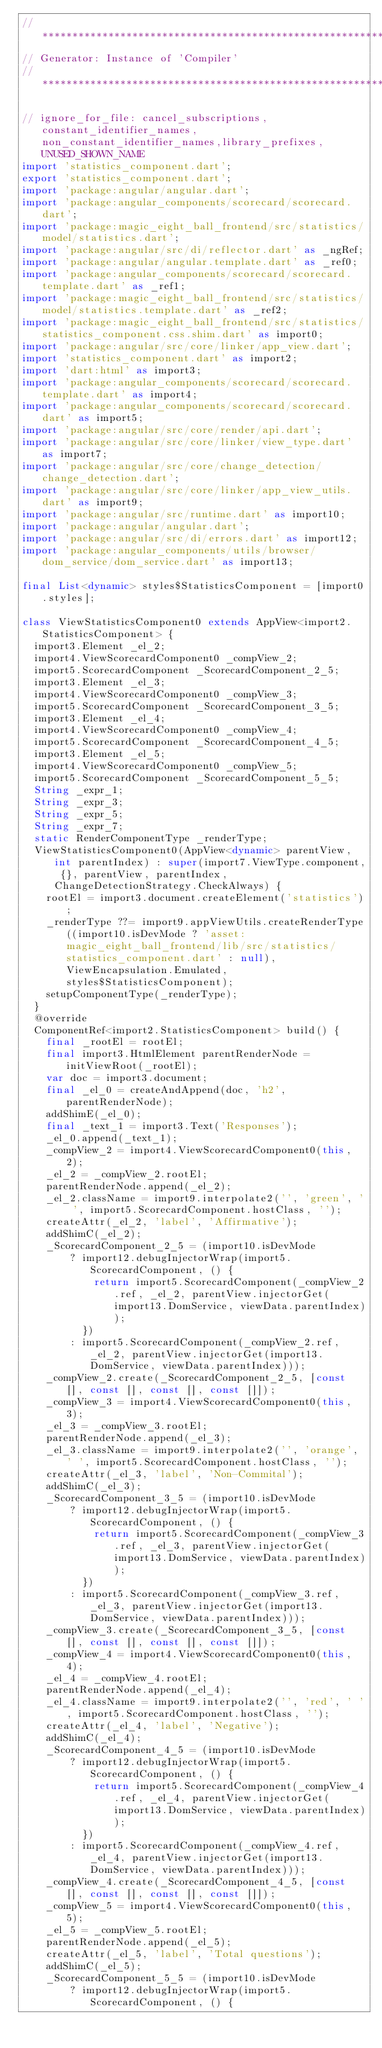Convert code to text. <code><loc_0><loc_0><loc_500><loc_500><_Dart_>// **************************************************************************
// Generator: Instance of 'Compiler'
// **************************************************************************

// ignore_for_file: cancel_subscriptions,constant_identifier_names,non_constant_identifier_names,library_prefixes,UNUSED_SHOWN_NAME
import 'statistics_component.dart';
export 'statistics_component.dart';
import 'package:angular/angular.dart';
import 'package:angular_components/scorecard/scorecard.dart';
import 'package:magic_eight_ball_frontend/src/statistics/model/statistics.dart';
import 'package:angular/src/di/reflector.dart' as _ngRef;
import 'package:angular/angular.template.dart' as _ref0;
import 'package:angular_components/scorecard/scorecard.template.dart' as _ref1;
import 'package:magic_eight_ball_frontend/src/statistics/model/statistics.template.dart' as _ref2;
import 'package:magic_eight_ball_frontend/src/statistics/statistics_component.css.shim.dart' as import0;
import 'package:angular/src/core/linker/app_view.dart';
import 'statistics_component.dart' as import2;
import 'dart:html' as import3;
import 'package:angular_components/scorecard/scorecard.template.dart' as import4;
import 'package:angular_components/scorecard/scorecard.dart' as import5;
import 'package:angular/src/core/render/api.dart';
import 'package:angular/src/core/linker/view_type.dart' as import7;
import 'package:angular/src/core/change_detection/change_detection.dart';
import 'package:angular/src/core/linker/app_view_utils.dart' as import9;
import 'package:angular/src/runtime.dart' as import10;
import 'package:angular/angular.dart';
import 'package:angular/src/di/errors.dart' as import12;
import 'package:angular_components/utils/browser/dom_service/dom_service.dart' as import13;

final List<dynamic> styles$StatisticsComponent = [import0.styles];

class ViewStatisticsComponent0 extends AppView<import2.StatisticsComponent> {
  import3.Element _el_2;
  import4.ViewScorecardComponent0 _compView_2;
  import5.ScorecardComponent _ScorecardComponent_2_5;
  import3.Element _el_3;
  import4.ViewScorecardComponent0 _compView_3;
  import5.ScorecardComponent _ScorecardComponent_3_5;
  import3.Element _el_4;
  import4.ViewScorecardComponent0 _compView_4;
  import5.ScorecardComponent _ScorecardComponent_4_5;
  import3.Element _el_5;
  import4.ViewScorecardComponent0 _compView_5;
  import5.ScorecardComponent _ScorecardComponent_5_5;
  String _expr_1;
  String _expr_3;
  String _expr_5;
  String _expr_7;
  static RenderComponentType _renderType;
  ViewStatisticsComponent0(AppView<dynamic> parentView, int parentIndex) : super(import7.ViewType.component, {}, parentView, parentIndex, ChangeDetectionStrategy.CheckAlways) {
    rootEl = import3.document.createElement('statistics');
    _renderType ??= import9.appViewUtils.createRenderType((import10.isDevMode ? 'asset:magic_eight_ball_frontend/lib/src/statistics/statistics_component.dart' : null), ViewEncapsulation.Emulated, styles$StatisticsComponent);
    setupComponentType(_renderType);
  }
  @override
  ComponentRef<import2.StatisticsComponent> build() {
    final _rootEl = rootEl;
    final import3.HtmlElement parentRenderNode = initViewRoot(_rootEl);
    var doc = import3.document;
    final _el_0 = createAndAppend(doc, 'h2', parentRenderNode);
    addShimE(_el_0);
    final _text_1 = import3.Text('Responses');
    _el_0.append(_text_1);
    _compView_2 = import4.ViewScorecardComponent0(this, 2);
    _el_2 = _compView_2.rootEl;
    parentRenderNode.append(_el_2);
    _el_2.className = import9.interpolate2('', 'green', ' ', import5.ScorecardComponent.hostClass, '');
    createAttr(_el_2, 'label', 'Affirmative');
    addShimC(_el_2);
    _ScorecardComponent_2_5 = (import10.isDevMode
        ? import12.debugInjectorWrap(import5.ScorecardComponent, () {
            return import5.ScorecardComponent(_compView_2.ref, _el_2, parentView.injectorGet(import13.DomService, viewData.parentIndex));
          })
        : import5.ScorecardComponent(_compView_2.ref, _el_2, parentView.injectorGet(import13.DomService, viewData.parentIndex)));
    _compView_2.create(_ScorecardComponent_2_5, [const [], const [], const [], const []]);
    _compView_3 = import4.ViewScorecardComponent0(this, 3);
    _el_3 = _compView_3.rootEl;
    parentRenderNode.append(_el_3);
    _el_3.className = import9.interpolate2('', 'orange', ' ', import5.ScorecardComponent.hostClass, '');
    createAttr(_el_3, 'label', 'Non-Commital');
    addShimC(_el_3);
    _ScorecardComponent_3_5 = (import10.isDevMode
        ? import12.debugInjectorWrap(import5.ScorecardComponent, () {
            return import5.ScorecardComponent(_compView_3.ref, _el_3, parentView.injectorGet(import13.DomService, viewData.parentIndex));
          })
        : import5.ScorecardComponent(_compView_3.ref, _el_3, parentView.injectorGet(import13.DomService, viewData.parentIndex)));
    _compView_3.create(_ScorecardComponent_3_5, [const [], const [], const [], const []]);
    _compView_4 = import4.ViewScorecardComponent0(this, 4);
    _el_4 = _compView_4.rootEl;
    parentRenderNode.append(_el_4);
    _el_4.className = import9.interpolate2('', 'red', ' ', import5.ScorecardComponent.hostClass, '');
    createAttr(_el_4, 'label', 'Negative');
    addShimC(_el_4);
    _ScorecardComponent_4_5 = (import10.isDevMode
        ? import12.debugInjectorWrap(import5.ScorecardComponent, () {
            return import5.ScorecardComponent(_compView_4.ref, _el_4, parentView.injectorGet(import13.DomService, viewData.parentIndex));
          })
        : import5.ScorecardComponent(_compView_4.ref, _el_4, parentView.injectorGet(import13.DomService, viewData.parentIndex)));
    _compView_4.create(_ScorecardComponent_4_5, [const [], const [], const [], const []]);
    _compView_5 = import4.ViewScorecardComponent0(this, 5);
    _el_5 = _compView_5.rootEl;
    parentRenderNode.append(_el_5);
    createAttr(_el_5, 'label', 'Total questions');
    addShimC(_el_5);
    _ScorecardComponent_5_5 = (import10.isDevMode
        ? import12.debugInjectorWrap(import5.ScorecardComponent, () {</code> 